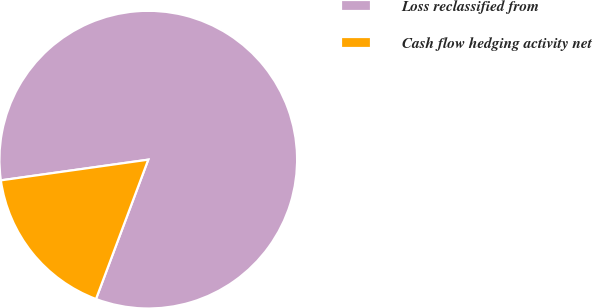Convert chart. <chart><loc_0><loc_0><loc_500><loc_500><pie_chart><fcel>Loss reclassified from<fcel>Cash flow hedging activity net<nl><fcel>82.93%<fcel>17.07%<nl></chart> 